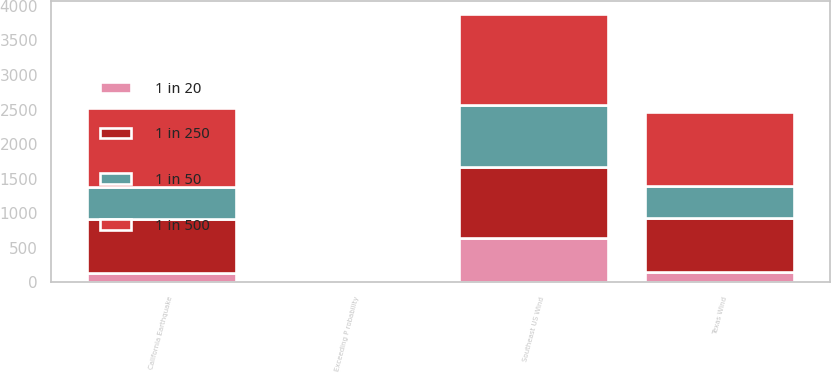Convert chart to OTSL. <chart><loc_0><loc_0><loc_500><loc_500><stacked_bar_chart><ecel><fcel>Exceeding P robability<fcel>Southeast US Wind<fcel>California Earthquake<fcel>Texas Wind<nl><fcel>1 in 20<fcel>5<fcel>639<fcel>136<fcel>158<nl><fcel>1 in 50<fcel>2<fcel>888<fcel>470<fcel>467<nl><fcel>1 in 250<fcel>1<fcel>1036<fcel>781<fcel>769<nl><fcel>1 in 500<fcel>0.4<fcel>1315<fcel>1132<fcel>1077<nl></chart> 